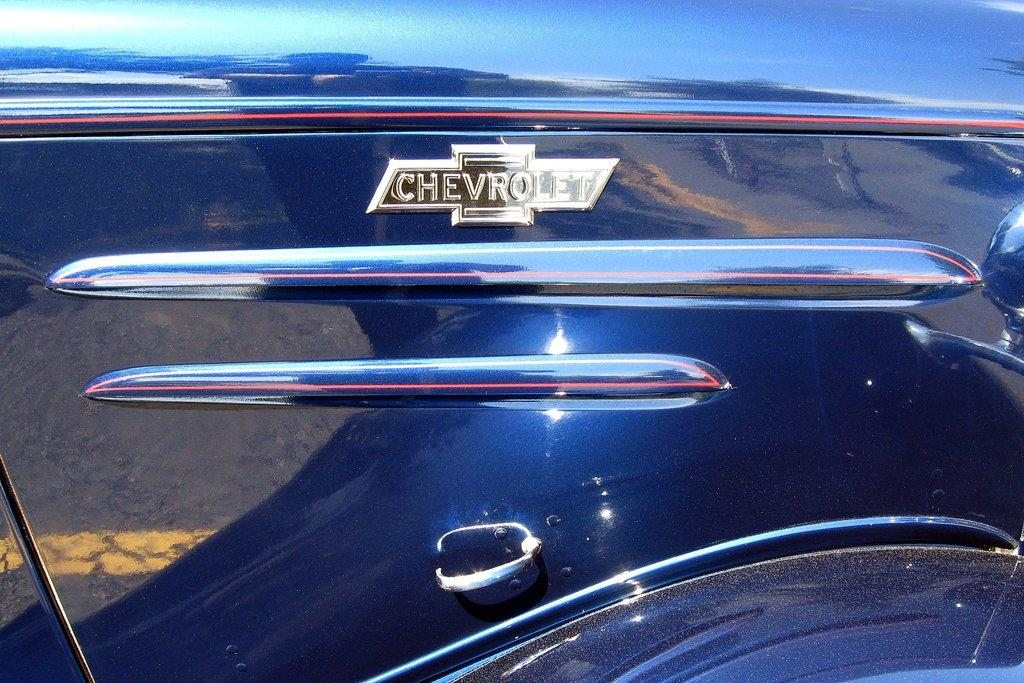What is the main feature of the image? There is a logo in the image. Where is the logo located? The logo is on a motor vehicle. How many ducks are visible in the image? There are no ducks present in the image. What type of patch is shown on the motor vehicle in the image? There is no patch shown on the motor vehicle in the image; only the logo is visible. 